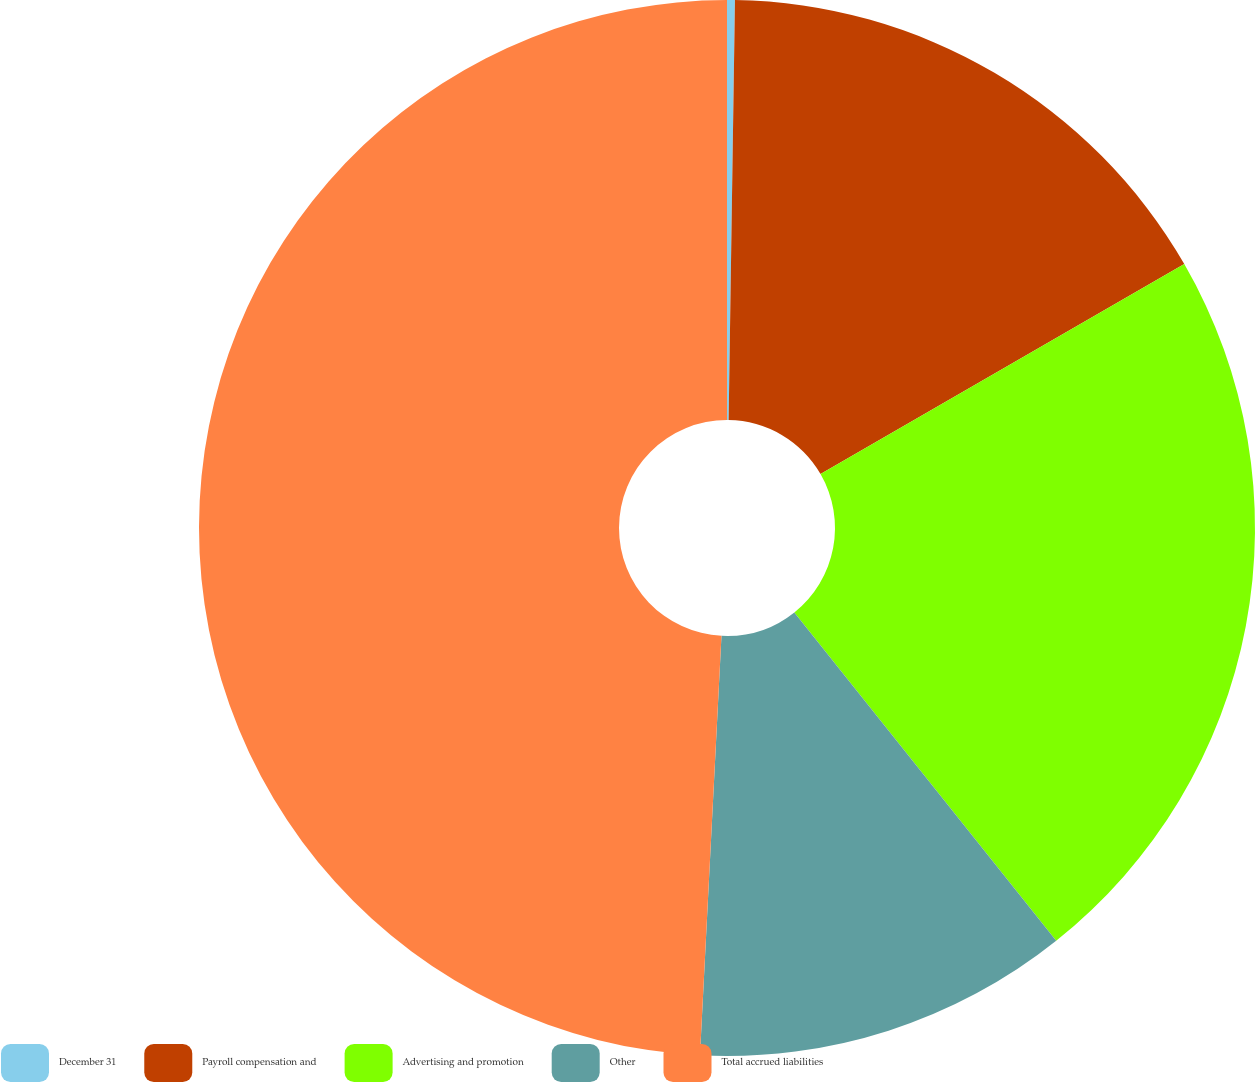Convert chart. <chart><loc_0><loc_0><loc_500><loc_500><pie_chart><fcel>December 31<fcel>Payroll compensation and<fcel>Advertising and promotion<fcel>Other<fcel>Total accrued liabilities<nl><fcel>0.24%<fcel>16.43%<fcel>22.62%<fcel>11.53%<fcel>49.19%<nl></chart> 